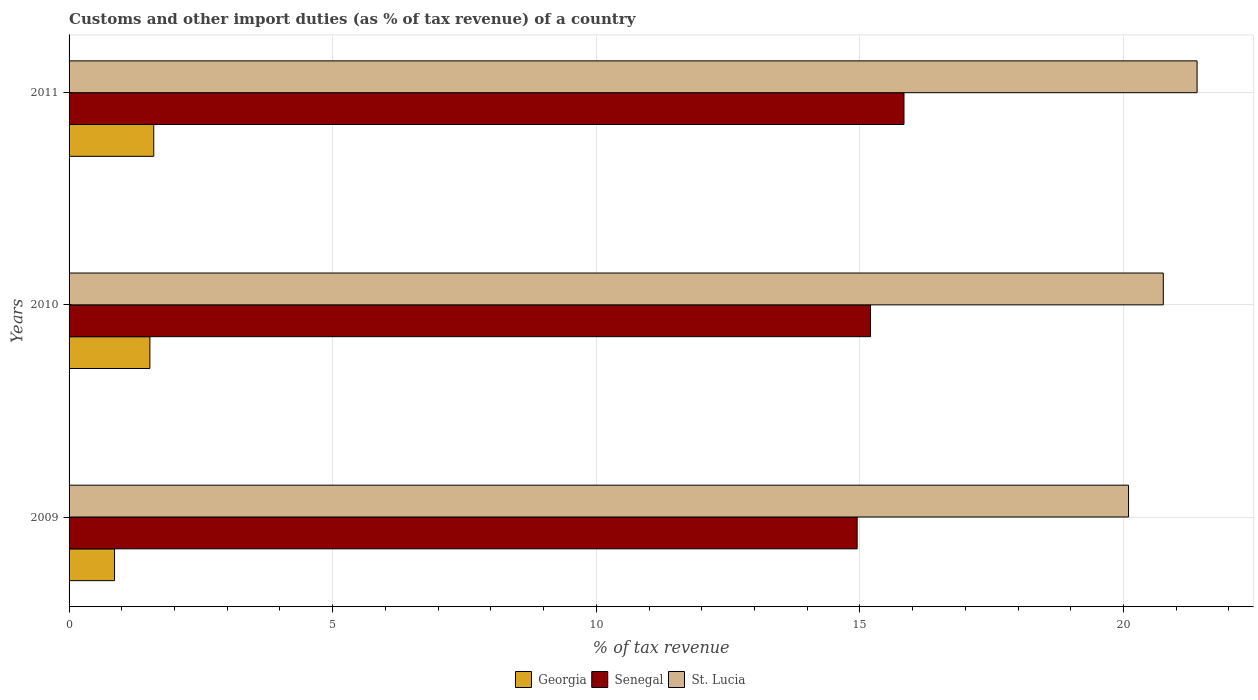How many different coloured bars are there?
Provide a short and direct response. 3. How many bars are there on the 1st tick from the top?
Make the answer very short. 3. What is the percentage of tax revenue from customs in Senegal in 2011?
Your answer should be very brief. 15.84. Across all years, what is the maximum percentage of tax revenue from customs in Senegal?
Provide a succinct answer. 15.84. Across all years, what is the minimum percentage of tax revenue from customs in Georgia?
Your answer should be compact. 0.86. In which year was the percentage of tax revenue from customs in Senegal minimum?
Give a very brief answer. 2009. What is the total percentage of tax revenue from customs in Georgia in the graph?
Your response must be concise. 4. What is the difference between the percentage of tax revenue from customs in St. Lucia in 2009 and that in 2010?
Keep it short and to the point. -0.66. What is the difference between the percentage of tax revenue from customs in Georgia in 2010 and the percentage of tax revenue from customs in St. Lucia in 2011?
Offer a very short reply. -19.86. What is the average percentage of tax revenue from customs in Senegal per year?
Ensure brevity in your answer.  15.33. In the year 2009, what is the difference between the percentage of tax revenue from customs in Georgia and percentage of tax revenue from customs in St. Lucia?
Give a very brief answer. -19.23. What is the ratio of the percentage of tax revenue from customs in Senegal in 2009 to that in 2011?
Offer a very short reply. 0.94. Is the percentage of tax revenue from customs in Georgia in 2009 less than that in 2011?
Offer a terse response. Yes. What is the difference between the highest and the second highest percentage of tax revenue from customs in Senegal?
Provide a short and direct response. 0.63. What is the difference between the highest and the lowest percentage of tax revenue from customs in Senegal?
Your response must be concise. 0.89. Is the sum of the percentage of tax revenue from customs in Georgia in 2009 and 2011 greater than the maximum percentage of tax revenue from customs in Senegal across all years?
Offer a very short reply. No. What does the 2nd bar from the top in 2009 represents?
Give a very brief answer. Senegal. What does the 3rd bar from the bottom in 2010 represents?
Your answer should be very brief. St. Lucia. Is it the case that in every year, the sum of the percentage of tax revenue from customs in St. Lucia and percentage of tax revenue from customs in Georgia is greater than the percentage of tax revenue from customs in Senegal?
Your answer should be compact. Yes. Are all the bars in the graph horizontal?
Keep it short and to the point. Yes. How many years are there in the graph?
Your response must be concise. 3. What is the difference between two consecutive major ticks on the X-axis?
Provide a succinct answer. 5. Where does the legend appear in the graph?
Ensure brevity in your answer.  Bottom center. What is the title of the graph?
Provide a succinct answer. Customs and other import duties (as % of tax revenue) of a country. What is the label or title of the X-axis?
Your answer should be very brief. % of tax revenue. What is the % of tax revenue in Georgia in 2009?
Keep it short and to the point. 0.86. What is the % of tax revenue in Senegal in 2009?
Give a very brief answer. 14.95. What is the % of tax revenue in St. Lucia in 2009?
Your answer should be compact. 20.1. What is the % of tax revenue of Georgia in 2010?
Keep it short and to the point. 1.53. What is the % of tax revenue in Senegal in 2010?
Make the answer very short. 15.2. What is the % of tax revenue in St. Lucia in 2010?
Your answer should be compact. 20.75. What is the % of tax revenue of Georgia in 2011?
Your answer should be compact. 1.61. What is the % of tax revenue of Senegal in 2011?
Provide a short and direct response. 15.84. What is the % of tax revenue of St. Lucia in 2011?
Your answer should be compact. 21.4. Across all years, what is the maximum % of tax revenue of Georgia?
Your answer should be very brief. 1.61. Across all years, what is the maximum % of tax revenue in Senegal?
Your answer should be very brief. 15.84. Across all years, what is the maximum % of tax revenue of St. Lucia?
Give a very brief answer. 21.4. Across all years, what is the minimum % of tax revenue in Georgia?
Offer a very short reply. 0.86. Across all years, what is the minimum % of tax revenue in Senegal?
Provide a succinct answer. 14.95. Across all years, what is the minimum % of tax revenue in St. Lucia?
Make the answer very short. 20.1. What is the total % of tax revenue in Georgia in the graph?
Your answer should be very brief. 4. What is the total % of tax revenue of Senegal in the graph?
Ensure brevity in your answer.  45.99. What is the total % of tax revenue of St. Lucia in the graph?
Make the answer very short. 62.25. What is the difference between the % of tax revenue in Georgia in 2009 and that in 2010?
Offer a very short reply. -0.67. What is the difference between the % of tax revenue of Senegal in 2009 and that in 2010?
Give a very brief answer. -0.25. What is the difference between the % of tax revenue in St. Lucia in 2009 and that in 2010?
Make the answer very short. -0.66. What is the difference between the % of tax revenue in Georgia in 2009 and that in 2011?
Your response must be concise. -0.74. What is the difference between the % of tax revenue of Senegal in 2009 and that in 2011?
Ensure brevity in your answer.  -0.89. What is the difference between the % of tax revenue of St. Lucia in 2009 and that in 2011?
Provide a short and direct response. -1.3. What is the difference between the % of tax revenue in Georgia in 2010 and that in 2011?
Give a very brief answer. -0.07. What is the difference between the % of tax revenue of Senegal in 2010 and that in 2011?
Provide a short and direct response. -0.63. What is the difference between the % of tax revenue of St. Lucia in 2010 and that in 2011?
Provide a short and direct response. -0.64. What is the difference between the % of tax revenue in Georgia in 2009 and the % of tax revenue in Senegal in 2010?
Provide a short and direct response. -14.34. What is the difference between the % of tax revenue of Georgia in 2009 and the % of tax revenue of St. Lucia in 2010?
Keep it short and to the point. -19.89. What is the difference between the % of tax revenue in Senegal in 2009 and the % of tax revenue in St. Lucia in 2010?
Make the answer very short. -5.81. What is the difference between the % of tax revenue of Georgia in 2009 and the % of tax revenue of Senegal in 2011?
Your answer should be very brief. -14.97. What is the difference between the % of tax revenue in Georgia in 2009 and the % of tax revenue in St. Lucia in 2011?
Your answer should be compact. -20.53. What is the difference between the % of tax revenue of Senegal in 2009 and the % of tax revenue of St. Lucia in 2011?
Offer a very short reply. -6.45. What is the difference between the % of tax revenue in Georgia in 2010 and the % of tax revenue in Senegal in 2011?
Your response must be concise. -14.3. What is the difference between the % of tax revenue of Georgia in 2010 and the % of tax revenue of St. Lucia in 2011?
Provide a short and direct response. -19.86. What is the difference between the % of tax revenue in Senegal in 2010 and the % of tax revenue in St. Lucia in 2011?
Your response must be concise. -6.19. What is the average % of tax revenue of Georgia per year?
Your response must be concise. 1.33. What is the average % of tax revenue of Senegal per year?
Keep it short and to the point. 15.33. What is the average % of tax revenue in St. Lucia per year?
Make the answer very short. 20.75. In the year 2009, what is the difference between the % of tax revenue in Georgia and % of tax revenue in Senegal?
Provide a succinct answer. -14.09. In the year 2009, what is the difference between the % of tax revenue of Georgia and % of tax revenue of St. Lucia?
Provide a short and direct response. -19.23. In the year 2009, what is the difference between the % of tax revenue in Senegal and % of tax revenue in St. Lucia?
Ensure brevity in your answer.  -5.15. In the year 2010, what is the difference between the % of tax revenue in Georgia and % of tax revenue in Senegal?
Ensure brevity in your answer.  -13.67. In the year 2010, what is the difference between the % of tax revenue in Georgia and % of tax revenue in St. Lucia?
Provide a short and direct response. -19.22. In the year 2010, what is the difference between the % of tax revenue of Senegal and % of tax revenue of St. Lucia?
Make the answer very short. -5.55. In the year 2011, what is the difference between the % of tax revenue of Georgia and % of tax revenue of Senegal?
Offer a terse response. -14.23. In the year 2011, what is the difference between the % of tax revenue of Georgia and % of tax revenue of St. Lucia?
Your answer should be very brief. -19.79. In the year 2011, what is the difference between the % of tax revenue of Senegal and % of tax revenue of St. Lucia?
Offer a very short reply. -5.56. What is the ratio of the % of tax revenue in Georgia in 2009 to that in 2010?
Give a very brief answer. 0.56. What is the ratio of the % of tax revenue in Senegal in 2009 to that in 2010?
Your answer should be compact. 0.98. What is the ratio of the % of tax revenue of St. Lucia in 2009 to that in 2010?
Ensure brevity in your answer.  0.97. What is the ratio of the % of tax revenue in Georgia in 2009 to that in 2011?
Ensure brevity in your answer.  0.54. What is the ratio of the % of tax revenue of Senegal in 2009 to that in 2011?
Provide a short and direct response. 0.94. What is the ratio of the % of tax revenue in St. Lucia in 2009 to that in 2011?
Offer a very short reply. 0.94. What is the ratio of the % of tax revenue in Georgia in 2010 to that in 2011?
Your answer should be compact. 0.95. What is the ratio of the % of tax revenue of Senegal in 2010 to that in 2011?
Provide a succinct answer. 0.96. What is the ratio of the % of tax revenue in St. Lucia in 2010 to that in 2011?
Your response must be concise. 0.97. What is the difference between the highest and the second highest % of tax revenue in Georgia?
Provide a succinct answer. 0.07. What is the difference between the highest and the second highest % of tax revenue of Senegal?
Offer a terse response. 0.63. What is the difference between the highest and the second highest % of tax revenue of St. Lucia?
Provide a succinct answer. 0.64. What is the difference between the highest and the lowest % of tax revenue in Georgia?
Offer a terse response. 0.74. What is the difference between the highest and the lowest % of tax revenue in Senegal?
Offer a terse response. 0.89. What is the difference between the highest and the lowest % of tax revenue in St. Lucia?
Offer a very short reply. 1.3. 